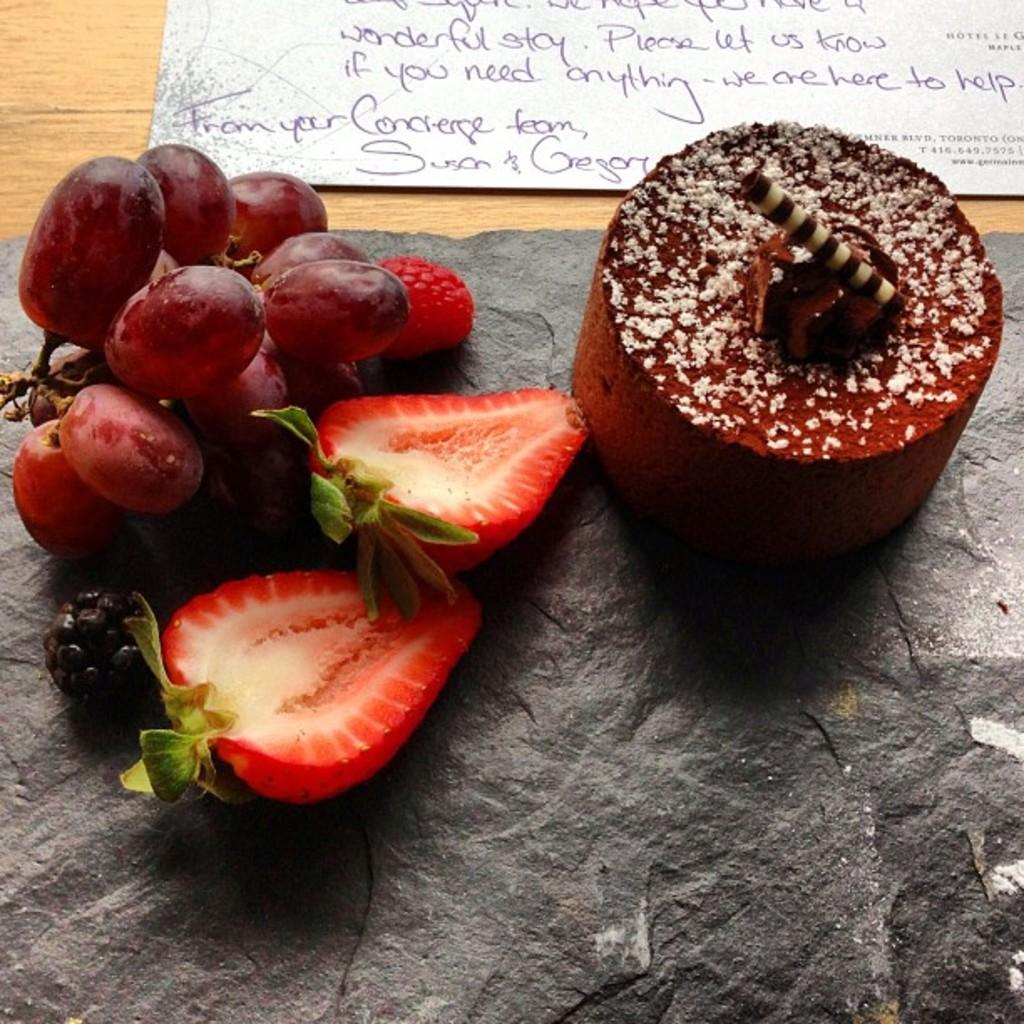What type of furniture is present in the image? There is a table in the image. What fruits can be seen on the table? The table has grapes, strawberries, and blackberries. What dessert is on the table? There is a cake on the table. Is there any written information in the image? Yes, there is a paper with a note in the image. What type of silk material is draped over the cake in the image? There is no silk material draped over the cake in the image; it is simply a cake on the table. What type of destruction can be seen happening to the table in the image? There is no destruction happening to the table in the image; it appears to be intact and supporting the various items on it. 